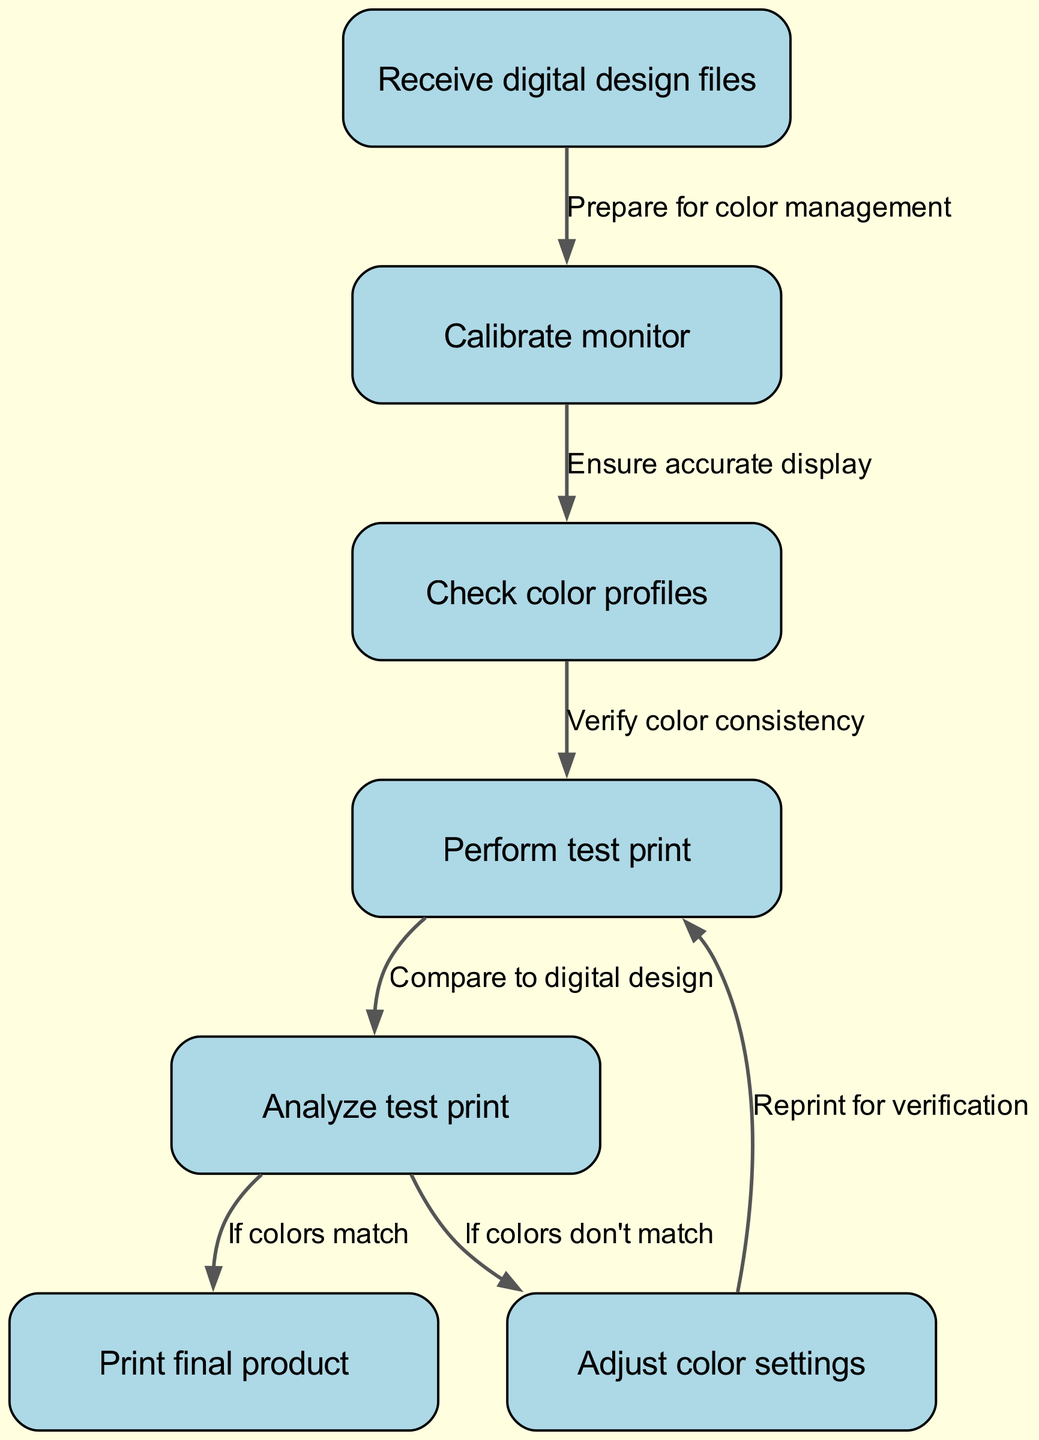What is the first step in the procedure? The flow chart starts with receiving digital design files. This is the initial action that kicks off the color calibration and management process.
Answer: Receive digital design files How many nodes are present in the diagram? The diagram contains a total of seven nodes, each representing a distinct step in the color calibration and management process.
Answer: Seven What is the connection between calibrating the monitor and checking color profiles? The edge connecting these two nodes indicates that after calibrating the monitor, the next step is to check color profiles to ensure accurate display.
Answer: Ensure accurate display What action is performed if the colors do not match during the analysis? If the analyzed test print does not match the digital design, the next action required is to adjust the color settings and reprint for verification.
Answer: Adjust color settings What represents the outcome if the colors match during the analysis? If the test print's colors match the digital design, the flow leads directly to the final step of printing the final product.
Answer: Print final product Which step follows after performing a test print? After performing a test print, the next step is to analyze the test print to determine if the colors match the digital design or need adjustment.
Answer: Analyze test print What does the edge labeled "If colors match" lead to? The edge labeled "If colors match" leads to the step of printing the final product, which signifies the successful end of the color management process.
Answer: Print final product What is the purpose of performing a test print? The purpose of performing a test print is to compare it to the digital design to ensure that the colors are being reproduced correctly.
Answer: Compare to digital design 